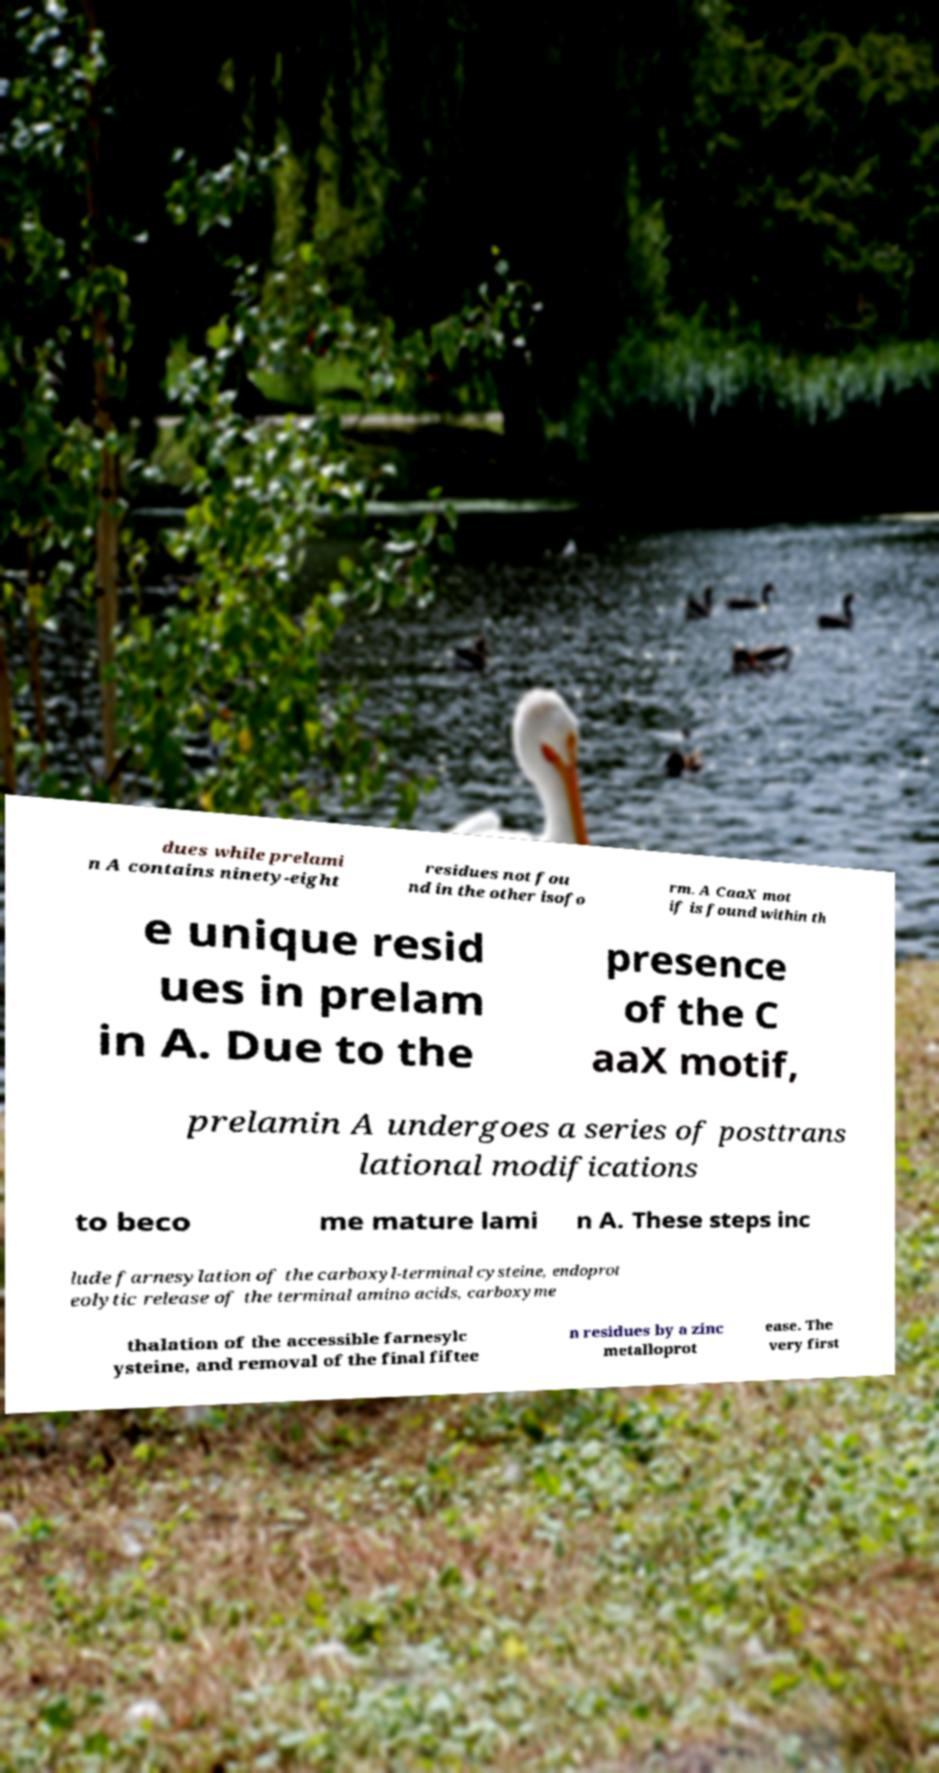Can you read and provide the text displayed in the image?This photo seems to have some interesting text. Can you extract and type it out for me? dues while prelami n A contains ninety-eight residues not fou nd in the other isofo rm. A CaaX mot if is found within th e unique resid ues in prelam in A. Due to the presence of the C aaX motif, prelamin A undergoes a series of posttrans lational modifications to beco me mature lami n A. These steps inc lude farnesylation of the carboxyl-terminal cysteine, endoprot eolytic release of the terminal amino acids, carboxyme thalation of the accessible farnesylc ysteine, and removal of the final fiftee n residues by a zinc metalloprot ease. The very first 